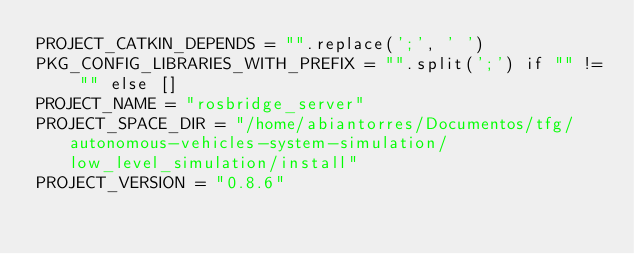Convert code to text. <code><loc_0><loc_0><loc_500><loc_500><_Python_>PROJECT_CATKIN_DEPENDS = "".replace(';', ' ')
PKG_CONFIG_LIBRARIES_WITH_PREFIX = "".split(';') if "" != "" else []
PROJECT_NAME = "rosbridge_server"
PROJECT_SPACE_DIR = "/home/abiantorres/Documentos/tfg/autonomous-vehicles-system-simulation/low_level_simulation/install"
PROJECT_VERSION = "0.8.6"
</code> 